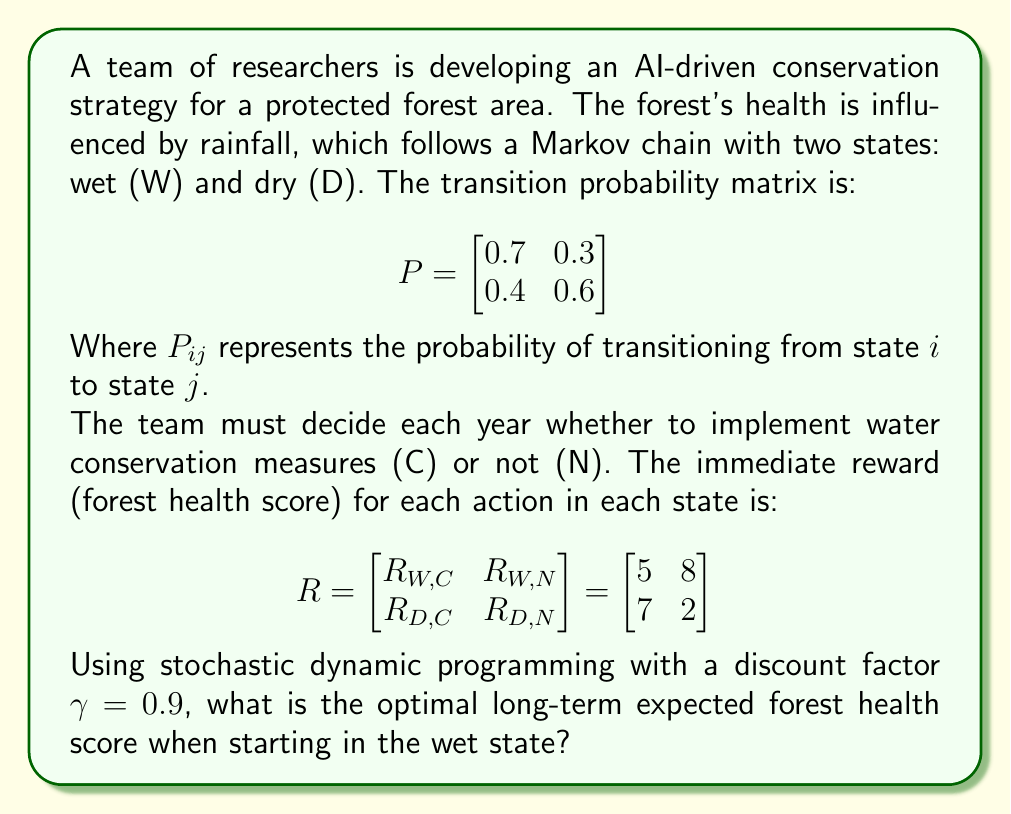Help me with this question. To solve this problem, we'll use the value iteration algorithm from stochastic dynamic programming:

1) Initialize the value function for both states:
   $V_0(W) = 0$, $V_0(D) = 0$

2) Update the value function iteratively:
   $V_{n+1}(s) = \max_a \{R(s,a) + \gamma \sum_{s'} P(s'|s,a)V_n(s')\}$

3) Repeat step 2 until convergence.

Let's perform the iterations:

Iteration 1:
$V_1(W) = \max \{5 + 0.9(0.7 \cdot 0 + 0.3 \cdot 0), 8 + 0.9(0.7 \cdot 0 + 0.3 \cdot 0)\} = \max\{5, 8\} = 8$
$V_1(D) = \max \{7 + 0.9(0.4 \cdot 0 + 0.6 \cdot 0), 2 + 0.9(0.4 \cdot 0 + 0.6 \cdot 0)\} = \max\{7, 2\} = 7$

Iteration 2:
$V_2(W) = \max \{5 + 0.9(0.7 \cdot 8 + 0.3 \cdot 7), 8 + 0.9(0.7 \cdot 8 + 0.3 \cdot 7)\} = \max\{11.79, 14.79\} = 14.79$
$V_2(D) = \max \{7 + 0.9(0.4 \cdot 8 + 0.6 \cdot 7), 2 + 0.9(0.4 \cdot 8 + 0.6 \cdot 7)\} = \max\{13.38, 8.38\} = 13.38$

Iteration 3:
$V_3(W) = \max \{5 + 0.9(0.7 \cdot 14.79 + 0.3 \cdot 13.38), 8 + 0.9(0.7 \cdot 14.79 + 0.3 \cdot 13.38)\} = \max\{17.29, 20.29\} = 20.29$
$V_3(D) = \max \{7 + 0.9(0.4 \cdot 14.79 + 0.6 \cdot 13.38), 2 + 0.9(0.4 \cdot 14.79 + 0.6 \cdot 13.38)\} = \max\{18.55, 13.55\} = 18.55$

We continue this process until the values converge. After several more iterations, we get:

$V_{\infty}(W) \approx 22.76$
$V_{\infty}(D) \approx 20.98$

The optimal policy is to not implement water conservation measures (N) when in the wet state, and to implement them (C) when in the dry state.
Answer: 22.76 